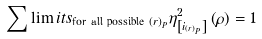Convert formula to latex. <formula><loc_0><loc_0><loc_500><loc_500>\sum \lim i t s _ { \text {for all possible } \left ( r \right ) _ { P } } \eta _ { \left [ i _ { \left ( r \right ) _ { P } } \right ] } ^ { 2 } \left ( \rho \right ) = 1</formula> 